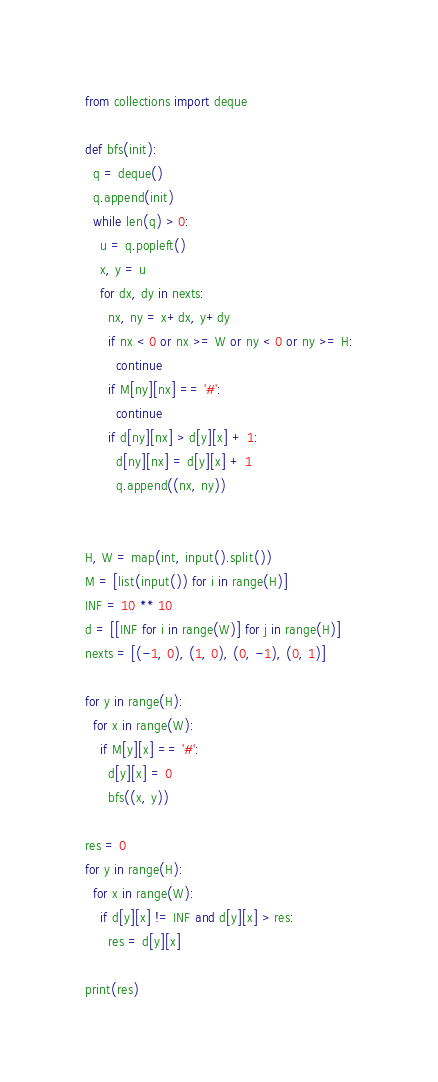Convert code to text. <code><loc_0><loc_0><loc_500><loc_500><_Python_>from collections import deque

def bfs(init):
  q = deque()
  q.append(init)
  while len(q) > 0:
    u = q.popleft()
    x, y = u
    for dx, dy in nexts:
      nx, ny = x+dx, y+dy
      if nx < 0 or nx >= W or ny < 0 or ny >= H:
        continue
      if M[ny][nx] == '#':
        continue
      if d[ny][nx] > d[y][x] + 1:
        d[ny][nx] = d[y][x] + 1
        q.append((nx, ny))


H, W = map(int, input().split())
M = [list(input()) for i in range(H)]
INF = 10 ** 10
d = [[INF for i in range(W)] for j in range(H)]
nexts = [(-1, 0), (1, 0), (0, -1), (0, 1)]

for y in range(H):
  for x in range(W):
    if M[y][x] == '#':
      d[y][x] = 0
      bfs((x, y))

res = 0
for y in range(H):
  for x in range(W):
    if d[y][x] != INF and d[y][x] > res:
      res = d[y][x]

print(res)
</code> 